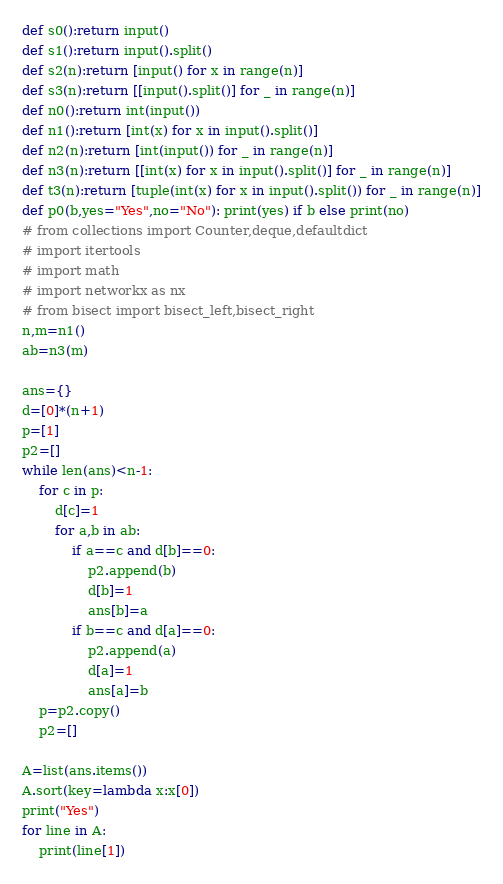<code> <loc_0><loc_0><loc_500><loc_500><_Python_>
def s0():return input()
def s1():return input().split()
def s2(n):return [input() for x in range(n)]
def s3(n):return [[input().split()] for _ in range(n)]
def n0():return int(input())
def n1():return [int(x) for x in input().split()]
def n2(n):return [int(input()) for _ in range(n)]
def n3(n):return [[int(x) for x in input().split()] for _ in range(n)]
def t3(n):return [tuple(int(x) for x in input().split()) for _ in range(n)]
def p0(b,yes="Yes",no="No"): print(yes) if b else print(no)
# from collections import Counter,deque,defaultdict
# import itertools
# import math
# import networkx as nx
# from bisect import bisect_left,bisect_right
n,m=n1()
ab=n3(m)

ans={}
d=[0]*(n+1)
p=[1]
p2=[]
while len(ans)<n-1:
    for c in p:
        d[c]=1
        for a,b in ab:
            if a==c and d[b]==0:
                p2.append(b)
                d[b]=1
                ans[b]=a
            if b==c and d[a]==0:
                p2.append(a)
                d[a]=1
                ans[a]=b
    p=p2.copy()
    p2=[]

A=list(ans.items())
A.sort(key=lambda x:x[0])
print("Yes")
for line in A:
    print(line[1])</code> 